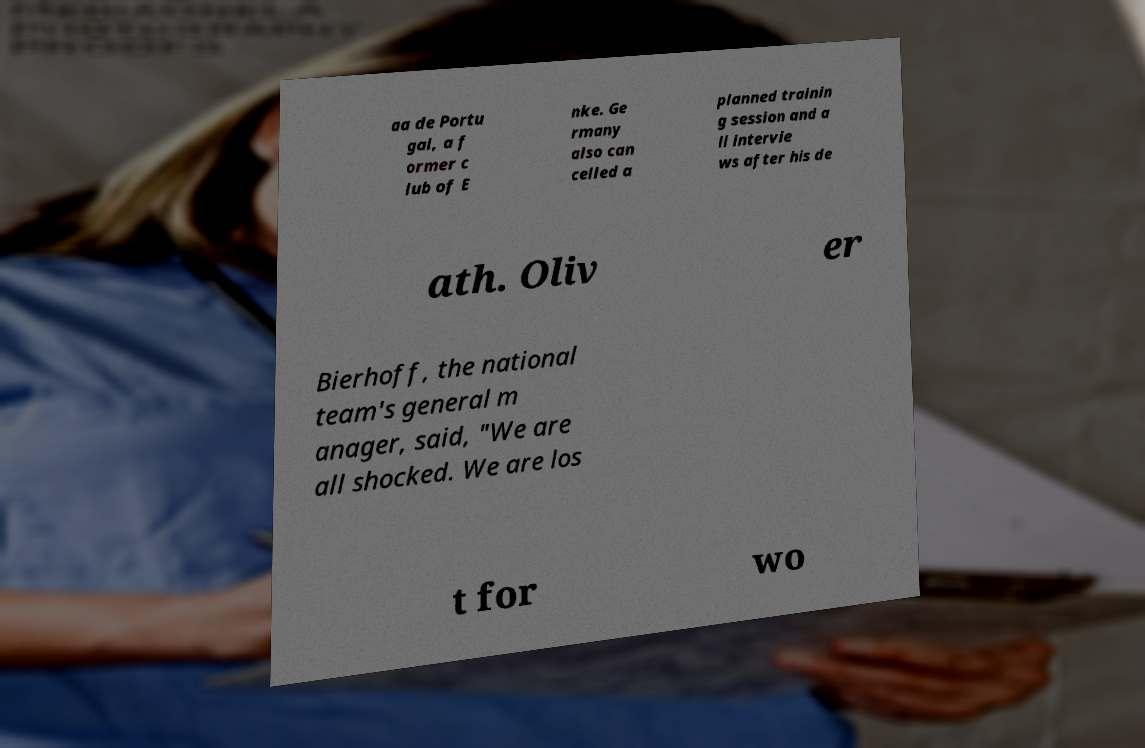Please identify and transcribe the text found in this image. aa de Portu gal, a f ormer c lub of E nke. Ge rmany also can celled a planned trainin g session and a ll intervie ws after his de ath. Oliv er Bierhoff, the national team's general m anager, said, "We are all shocked. We are los t for wo 